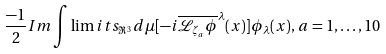<formula> <loc_0><loc_0><loc_500><loc_500>\frac { - 1 } { 2 } I m \int \lim i t s _ { \Re ^ { 3 } } d \mu [ - i \overline { \mathcal { L } _ { \zeta _ { a } } \phi } ^ { \lambda } ( x ) ] \phi _ { \lambda } ( x ) , \, a = 1 , \dots , 1 0</formula> 